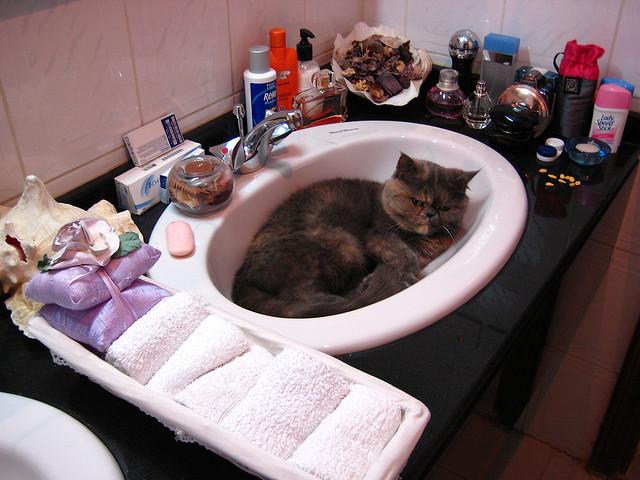Does the cat look happy?
Concise answer only. No. Should the cat be here?
Concise answer only. No. Do you see deodorant on the sink top?
Keep it brief. Yes. 